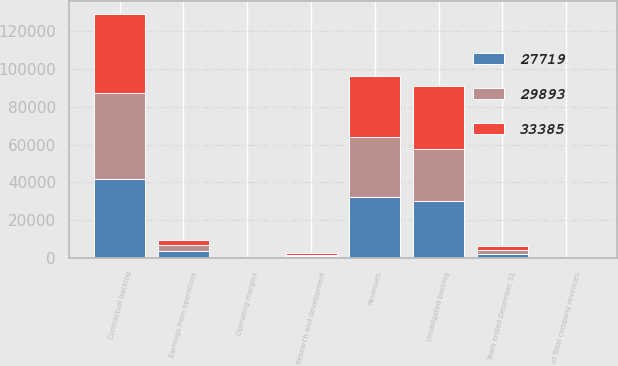Convert chart. <chart><loc_0><loc_0><loc_500><loc_500><stacked_bar_chart><ecel><fcel>Years ended December 31<fcel>Revenues<fcel>of Total company revenues<fcel>Earnings from operations<fcel>Operating margins<fcel>Research and development<fcel>Contractual backlog<fcel>Unobligated backlog<nl><fcel>29893<fcel>2008<fcel>32047<fcel>53<fcel>3232<fcel>10.1<fcel>933<fcel>45285<fcel>27719<nl><fcel>27719<fcel>2007<fcel>32052<fcel>48<fcel>3440<fcel>10.7<fcel>848<fcel>41788<fcel>29893<nl><fcel>33385<fcel>2006<fcel>32411<fcel>53<fcel>3031<fcel>9.4<fcel>786<fcel>42287<fcel>33385<nl></chart> 